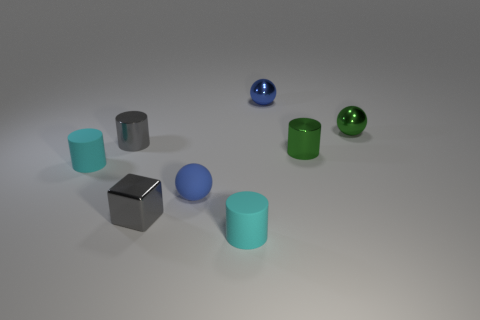Subtract 1 cylinders. How many cylinders are left? 3 Subtract all blue cylinders. Subtract all yellow cubes. How many cylinders are left? 4 Add 1 large purple shiny things. How many objects exist? 9 Subtract all cubes. How many objects are left? 7 Add 1 small green shiny cubes. How many small green shiny cubes exist? 1 Subtract 0 blue blocks. How many objects are left? 8 Subtract all green cylinders. Subtract all small spheres. How many objects are left? 4 Add 8 tiny blue metallic balls. How many tiny blue metallic balls are left? 9 